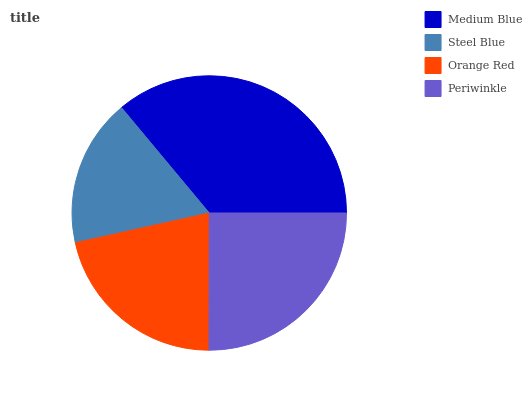Is Steel Blue the minimum?
Answer yes or no. Yes. Is Medium Blue the maximum?
Answer yes or no. Yes. Is Orange Red the minimum?
Answer yes or no. No. Is Orange Red the maximum?
Answer yes or no. No. Is Orange Red greater than Steel Blue?
Answer yes or no. Yes. Is Steel Blue less than Orange Red?
Answer yes or no. Yes. Is Steel Blue greater than Orange Red?
Answer yes or no. No. Is Orange Red less than Steel Blue?
Answer yes or no. No. Is Periwinkle the high median?
Answer yes or no. Yes. Is Orange Red the low median?
Answer yes or no. Yes. Is Orange Red the high median?
Answer yes or no. No. Is Periwinkle the low median?
Answer yes or no. No. 